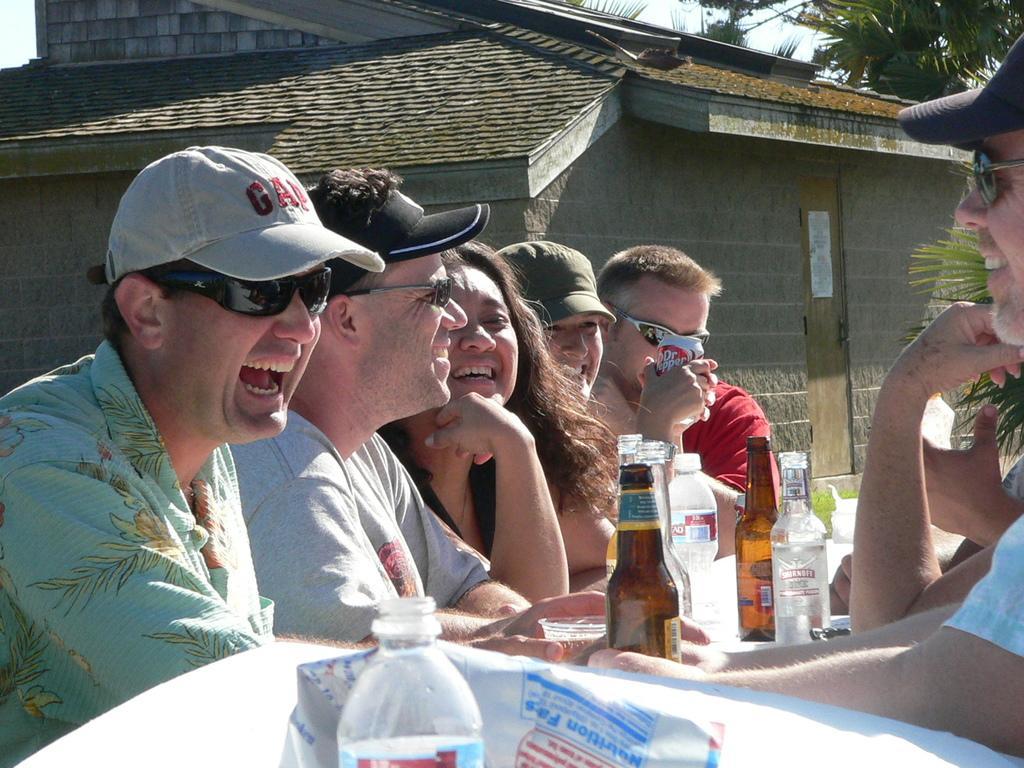In one or two sentences, can you explain what this image depicts? There are people sitting and we can see bottles. Background we can see house,trees and sky. 